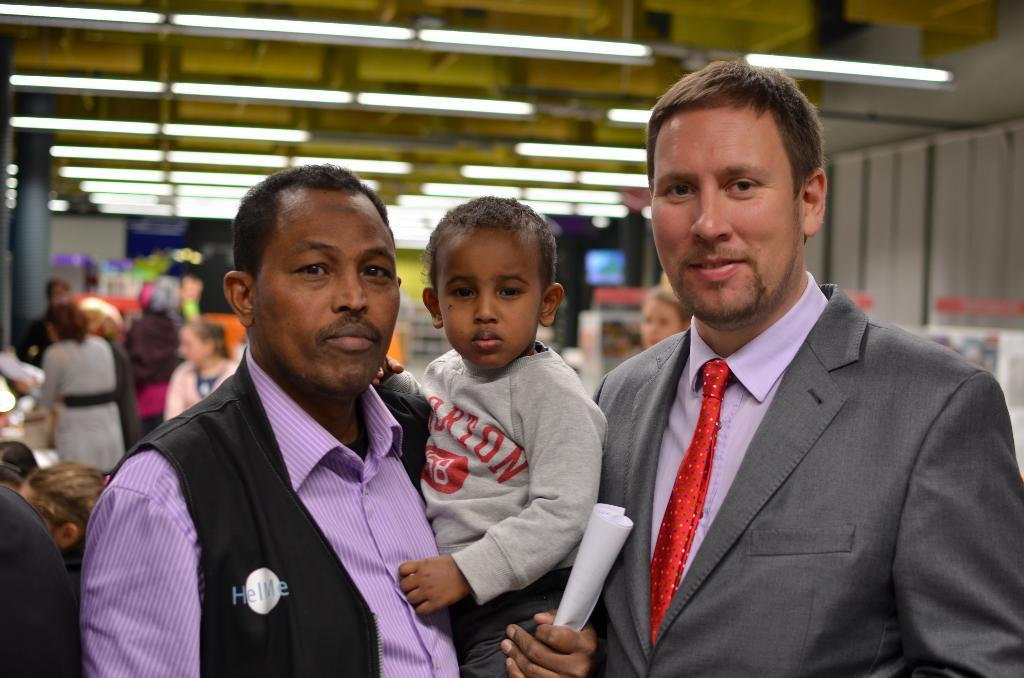How many persons are in the image? There are persons in the image. What can be seen in the background of the image? In the background of the image, there are lights, a wall, a pillar, and other objects. Can you describe the wall in the background? The wall is a part of the background in the image. What might be the purpose of the pillar in the background? The pillar in the background could be a structural support or a decorative element. How many visitors can be seen in the image? There is no mention of visitors in the image. 